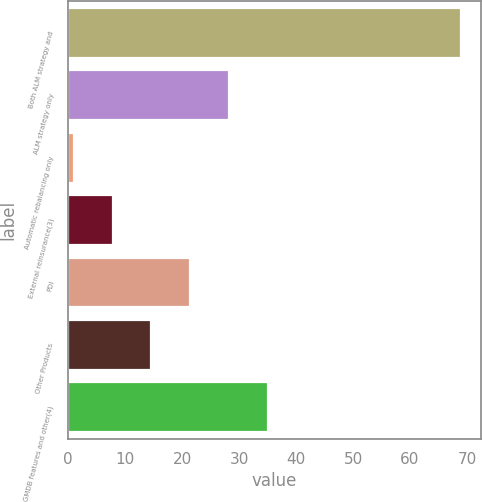Convert chart. <chart><loc_0><loc_0><loc_500><loc_500><bar_chart><fcel>Both ALM strategy and<fcel>ALM strategy only<fcel>Automatic rebalancing only<fcel>External reinsurance(3)<fcel>PDI<fcel>Other Products<fcel>GMDB features and other(4)<nl><fcel>69<fcel>28.2<fcel>1<fcel>7.8<fcel>21.4<fcel>14.6<fcel>35<nl></chart> 